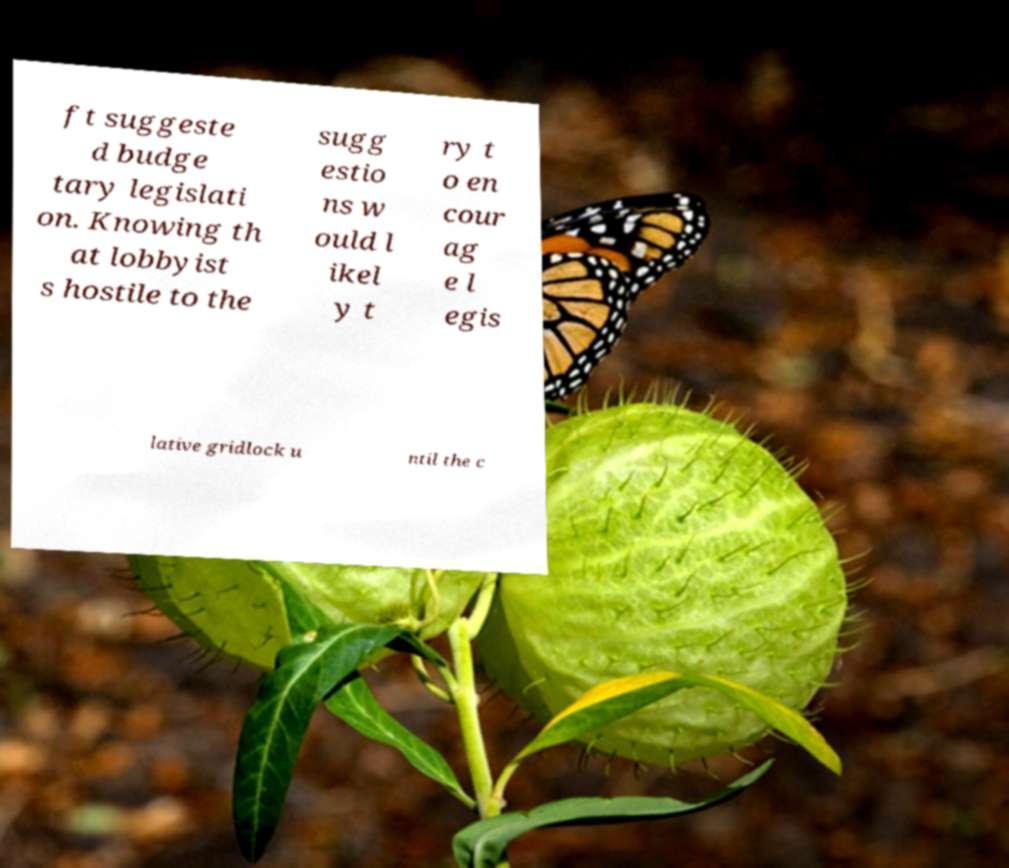Could you extract and type out the text from this image? ft suggeste d budge tary legislati on. Knowing th at lobbyist s hostile to the sugg estio ns w ould l ikel y t ry t o en cour ag e l egis lative gridlock u ntil the c 